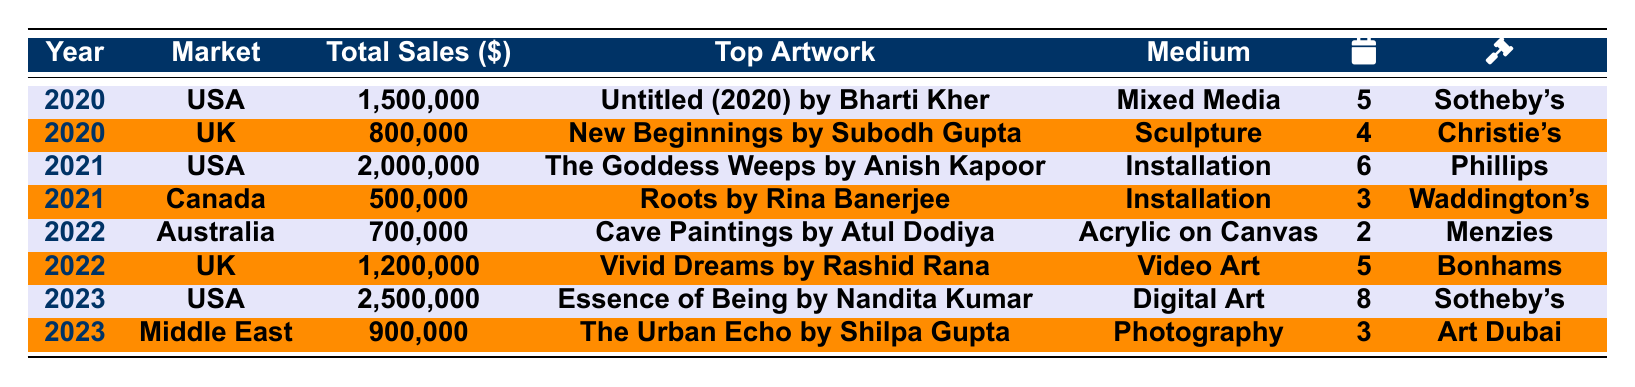What was the total sales of Indian artworks in the USA in 2023? The total sales in the USA for 2023 is listed in the table as 2,500,000.
Answer: 2,500,000 Which artwork achieved the highest sales in 2021? The table shows that "The Goddess Weeps by Anish Kapoor" had the highest sales in 2021, totaling 2,000,000.
Answer: The Goddess Weeps by Anish Kapoor How many notable exhibitions were there for the top artwork in the UK in 2022? By referring to the table, "Vivid Dreams by Rashid Rana," the top artwork in the UK for 2022, had 5 notable exhibitions.
Answer: 5 What was the difference in total sales between the USA in 2020 and 2021? The total sales for the USA in 2020 were 1,500,000 and in 2021 were 2,000,000. The difference is 2,000,000 - 1,500,000 = 500,000.
Answer: 500,000 Did Canada have any artworks with sales exceeding 600,000 from 2020 to 2023? Referring to the table, the only artwork sales in Canada were 500,000 in 2021, which does not exceed 600,000.
Answer: No What was the total sales for Indian artworks in the UK from 2020 to 2022? The sales in the UK were 800,000 in 2020 and 1,200,000 in 2022. Summing these gives 800,000 + 1,200,000 = 2,000,000.
Answer: 2,000,000 In which year did the highest total sales occur for Indian artworks, and what was the amount? The highest total sales were in 2023 at 2,500,000 for the USA.
Answer: 2023, 2,500,000 Which medium had the best-selling artwork in 2022, and what was the sales amount? The best-selling artwork in 2022 was "Vivid Dreams by Rashid Rana," which is categorized under Video Art with sales of 1,200,000.
Answer: Video Art, 1,200,000 How many notable exhibitions were there for the top artwork in the USA in 2020 compared to 2023? The top artwork in 2020 had 5 notable exhibitions (Bharti Kher), while in 2023, there were 8 notable exhibitions (Nandita Kumar). Thus, the difference is 8 - 5 = 3 more exhibitions in 2023.
Answer: 3 more exhibitions Was the total sales of artworks in the Middle East greater than the total sales in Canada for 2021? The total sales for the Middle East in 2023 were 900,000, while Canada's sales in 2021 were 500,000. As 900,000 > 500,000, the statement is true.
Answer: Yes 